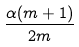<formula> <loc_0><loc_0><loc_500><loc_500>\frac { \alpha ( m + 1 ) } { 2 m }</formula> 